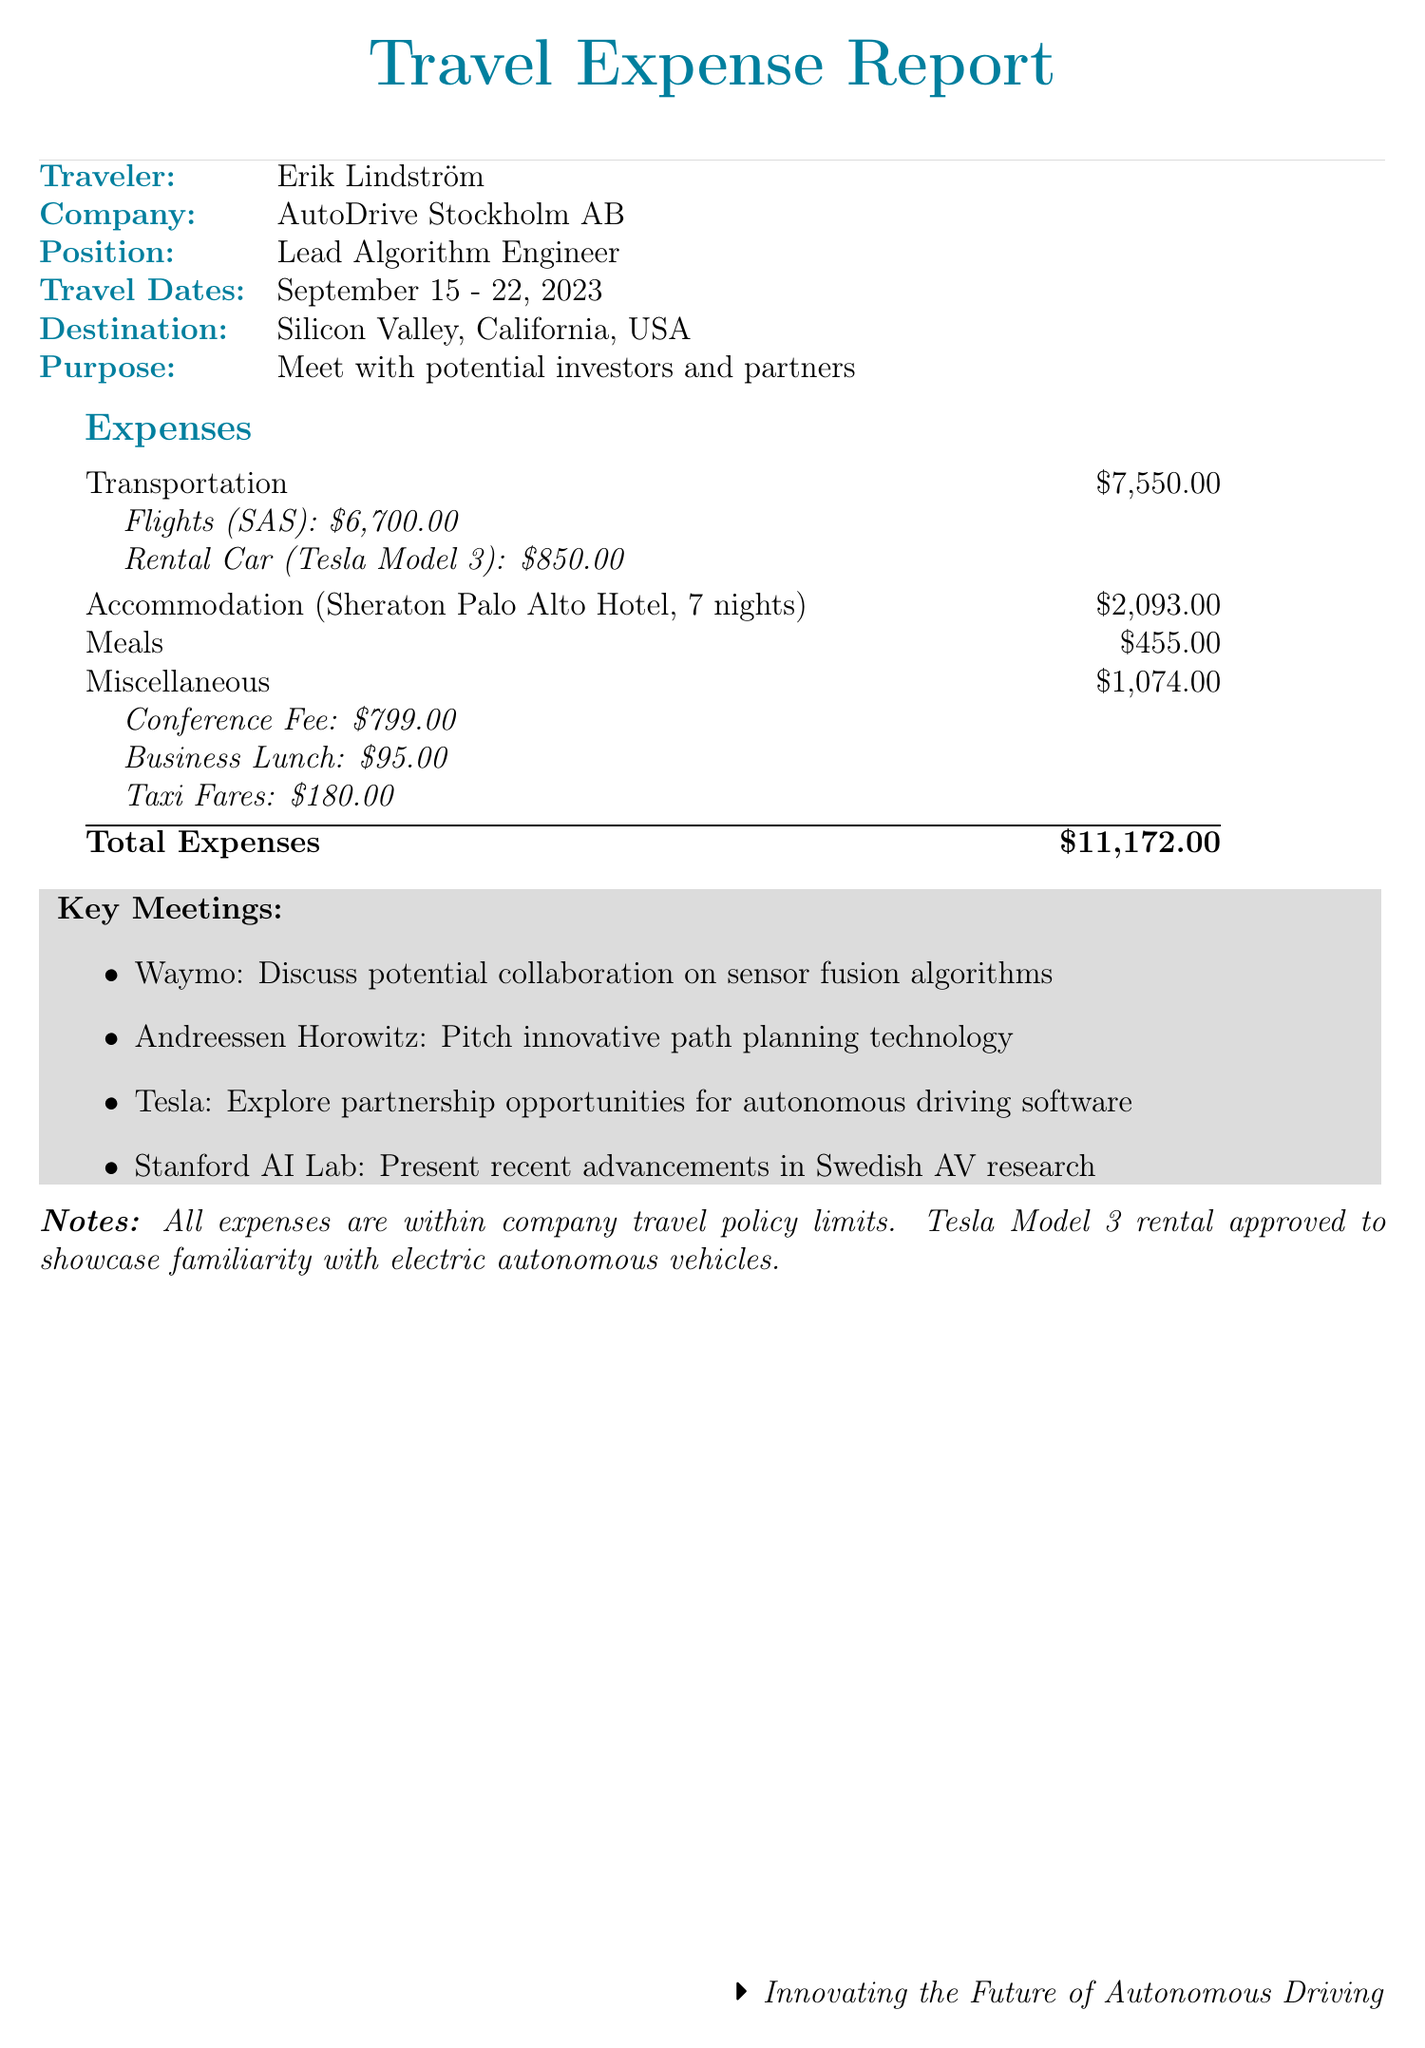What is the name of the traveler? The document states that the traveler is Erik Lindström.
Answer: Erik Lindström What was the total cost for transportation? The total cost for transportation, including flights and rental car, is listed as $7,550.00.
Answer: $7,550.00 Which hotel did the traveler stay at? The document specifies that the accommodation was at Sheraton Palo Alto Hotel.
Answer: Sheraton Palo Alto Hotel How many nights did the traveler stay? The total number of nights for the accommodation is mentioned as 7.
Answer: 7 What is the purpose of the trip? The document indicates that the purpose is to meet with potential investors and partners in the autonomous vehicle industry.
Answer: Meet with potential investors and partners How much did the traveler spend on meals? The total cost of meals listed in the document amounts to $455.00.
Answer: $455.00 What was the cost of the flight from Stockholm to San Francisco? The document indicates that the flight cost from Stockholm to San Francisco was $3,450.00.
Answer: $3,450.00 Which company did the traveler meet with on September 19? The document notes that the traveler had a meeting with Tesla on that date.
Answer: Tesla What was the attendance fee for the conference? The document specifies that the attendance fee for the conference was $799.00.
Answer: $799.00 What type of rental car was used? The document lists that the rental car was a Tesla Model 3.
Answer: Tesla Model 3 